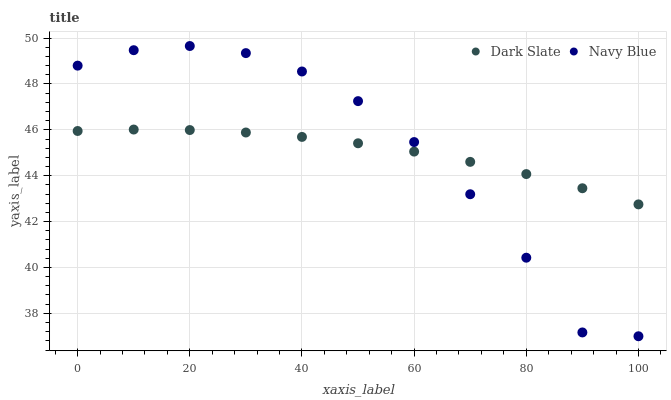Does Dark Slate have the minimum area under the curve?
Answer yes or no. Yes. Does Navy Blue have the maximum area under the curve?
Answer yes or no. Yes. Does Navy Blue have the minimum area under the curve?
Answer yes or no. No. Is Dark Slate the smoothest?
Answer yes or no. Yes. Is Navy Blue the roughest?
Answer yes or no. Yes. Is Navy Blue the smoothest?
Answer yes or no. No. Does Navy Blue have the lowest value?
Answer yes or no. Yes. Does Navy Blue have the highest value?
Answer yes or no. Yes. Does Navy Blue intersect Dark Slate?
Answer yes or no. Yes. Is Navy Blue less than Dark Slate?
Answer yes or no. No. Is Navy Blue greater than Dark Slate?
Answer yes or no. No. 